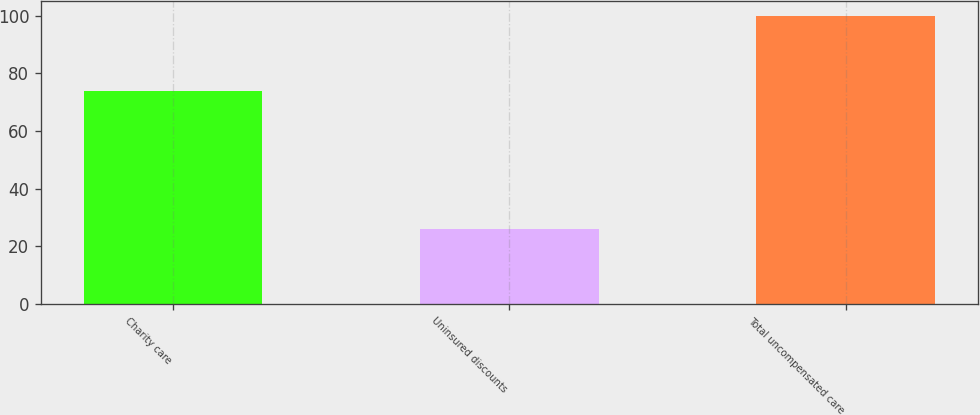<chart> <loc_0><loc_0><loc_500><loc_500><bar_chart><fcel>Charity care<fcel>Uninsured discounts<fcel>Total uncompensated care<nl><fcel>74<fcel>26<fcel>100<nl></chart> 